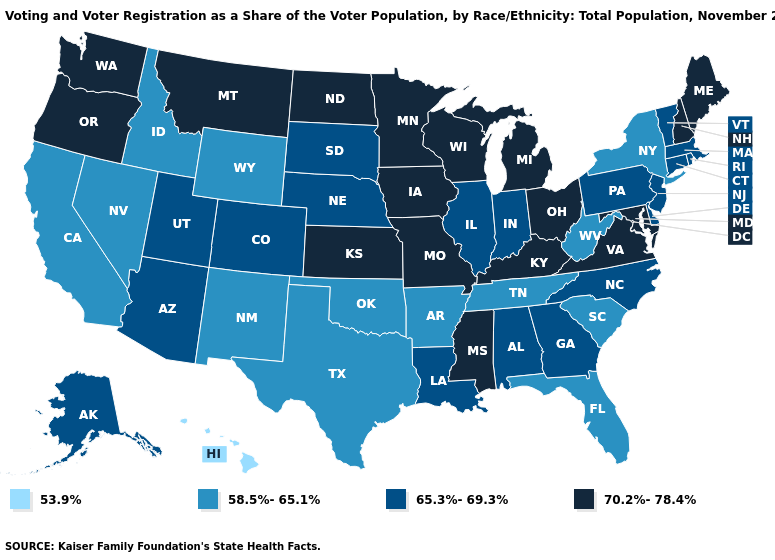What is the value of Indiana?
Quick response, please. 65.3%-69.3%. Name the states that have a value in the range 53.9%?
Concise answer only. Hawaii. What is the highest value in states that border Colorado?
Quick response, please. 70.2%-78.4%. What is the value of Idaho?
Quick response, please. 58.5%-65.1%. Does New Hampshire have the highest value in the Northeast?
Short answer required. Yes. Among the states that border Missouri , does Nebraska have the lowest value?
Short answer required. No. Does the first symbol in the legend represent the smallest category?
Short answer required. Yes. Does Arizona have a lower value than Indiana?
Be succinct. No. Which states have the highest value in the USA?
Write a very short answer. Iowa, Kansas, Kentucky, Maine, Maryland, Michigan, Minnesota, Mississippi, Missouri, Montana, New Hampshire, North Dakota, Ohio, Oregon, Virginia, Washington, Wisconsin. What is the highest value in states that border New Hampshire?
Give a very brief answer. 70.2%-78.4%. Name the states that have a value in the range 58.5%-65.1%?
Keep it brief. Arkansas, California, Florida, Idaho, Nevada, New Mexico, New York, Oklahoma, South Carolina, Tennessee, Texas, West Virginia, Wyoming. What is the highest value in the USA?
Answer briefly. 70.2%-78.4%. What is the value of Arizona?
Concise answer only. 65.3%-69.3%. What is the value of Nebraska?
Short answer required. 65.3%-69.3%. 